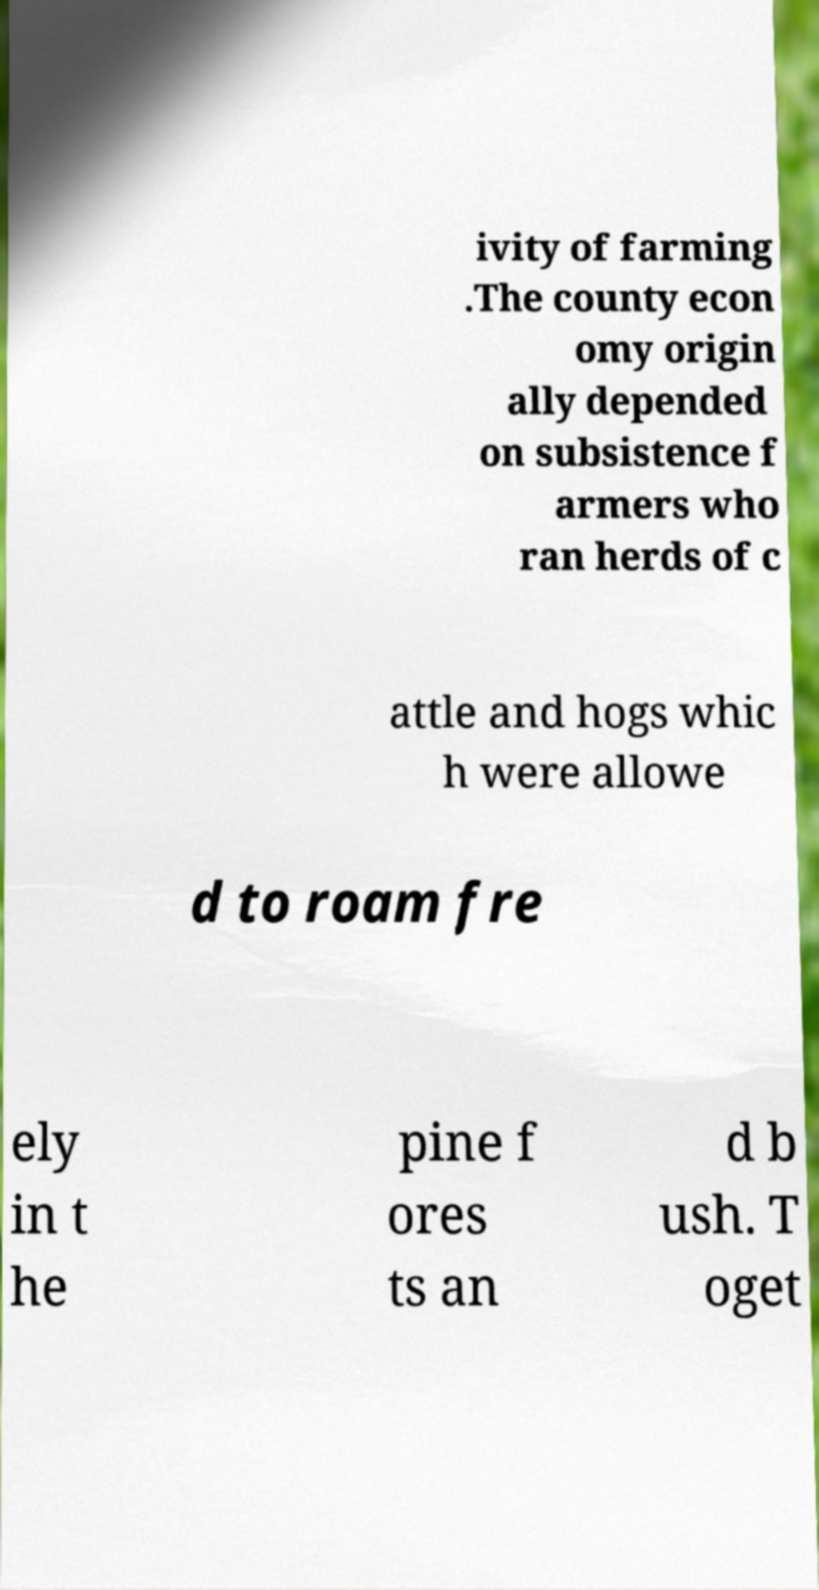Can you accurately transcribe the text from the provided image for me? ivity of farming .The county econ omy origin ally depended on subsistence f armers who ran herds of c attle and hogs whic h were allowe d to roam fre ely in t he pine f ores ts an d b ush. T oget 